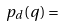Convert formula to latex. <formula><loc_0><loc_0><loc_500><loc_500>p _ { d } ( q ) =</formula> 